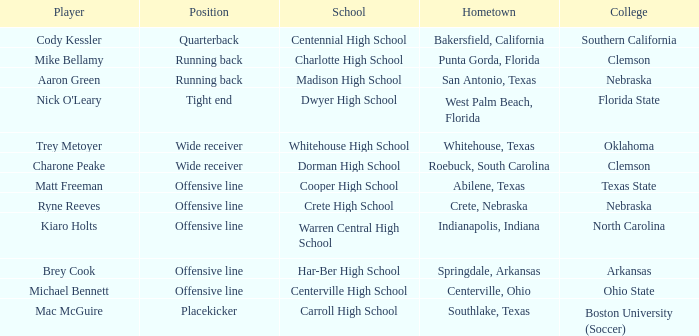What college did Matt Freeman go to? Texas State. 